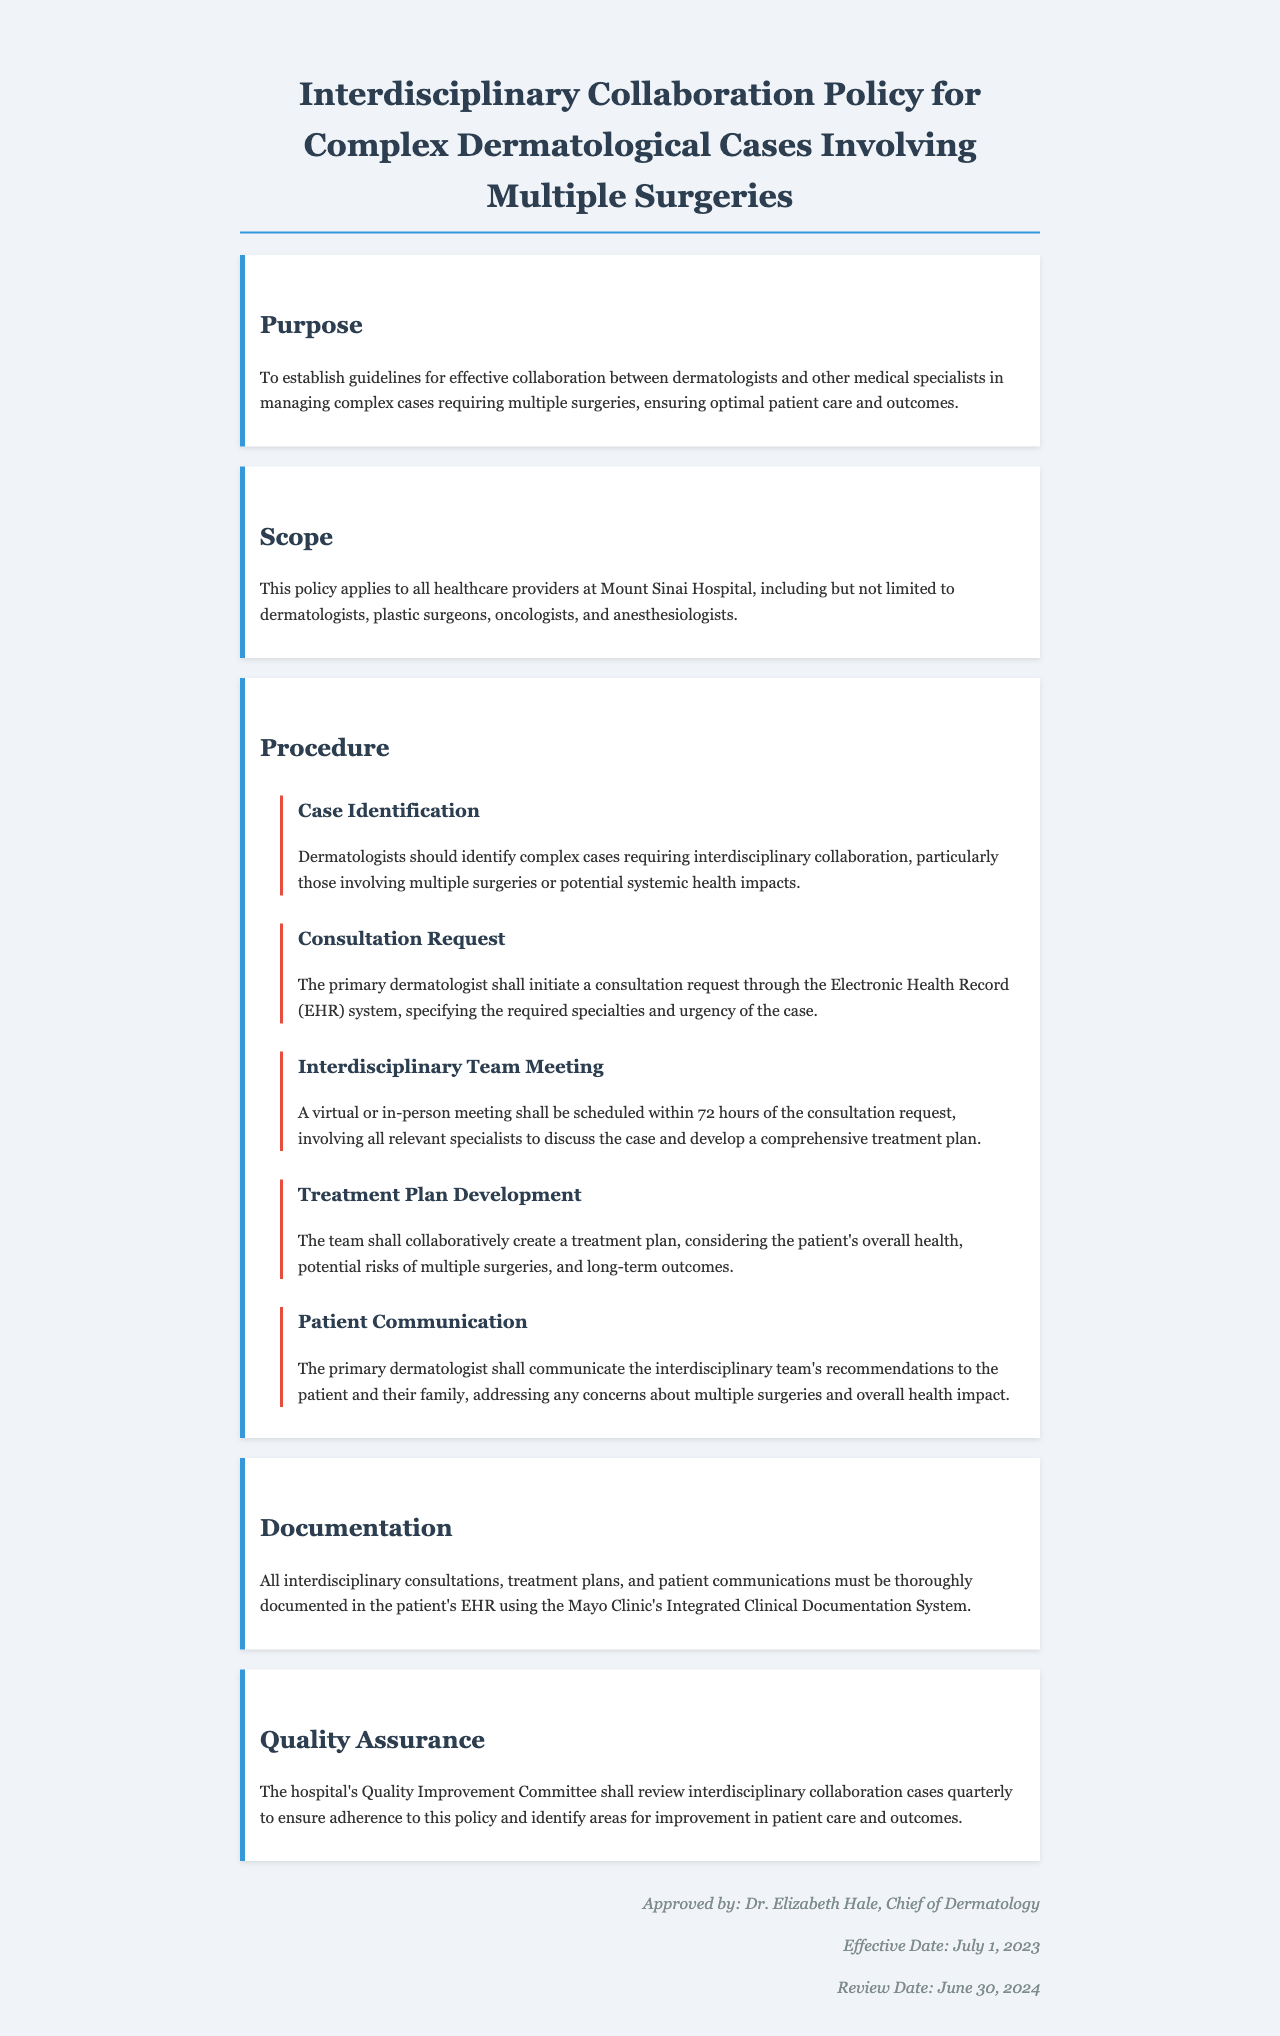What is the purpose of the policy? The purpose is to establish guidelines for effective collaboration between dermatologists and other medical specialists in managing complex cases requiring multiple surgeries, ensuring optimal patient care and outcomes.
Answer: To establish guidelines for effective collaboration Who is included in the scope of the policy? The scope applies to all healthcare providers at Mount Sinai Hospital, including dermatologists, plastic surgeons, oncologists, and anesthesiologists.
Answer: All healthcare providers at Mount Sinai Hospital How soon should the interdisciplinary team meeting be scheduled after a consultation request? The policy states that a virtual or in-person meeting shall be scheduled within 72 hours of the consultation request.
Answer: Within 72 hours What is required in the treatment plan development? The team shall collaboratively create a treatment plan, considering the patient's overall health, potential risks of multiple surgeries, and long-term outcomes.
Answer: Collaborative creation considering overall health What must be documented in the patient’s EHR? All interdisciplinary consultations, treatment plans, and patient communications must be thoroughly documented in the patient's EHR using the Mayo Clinic's Integrated Clinical Documentation System.
Answer: All interdisciplinary consultations, treatment plans, and communications When was the policy approved? The policy was approved by Dr. Elizabeth Hale, Chief of Dermatology, on July 1, 2023.
Answer: July 1, 2023 